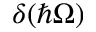<formula> <loc_0><loc_0><loc_500><loc_500>\delta ( \hbar { \Omega } )</formula> 